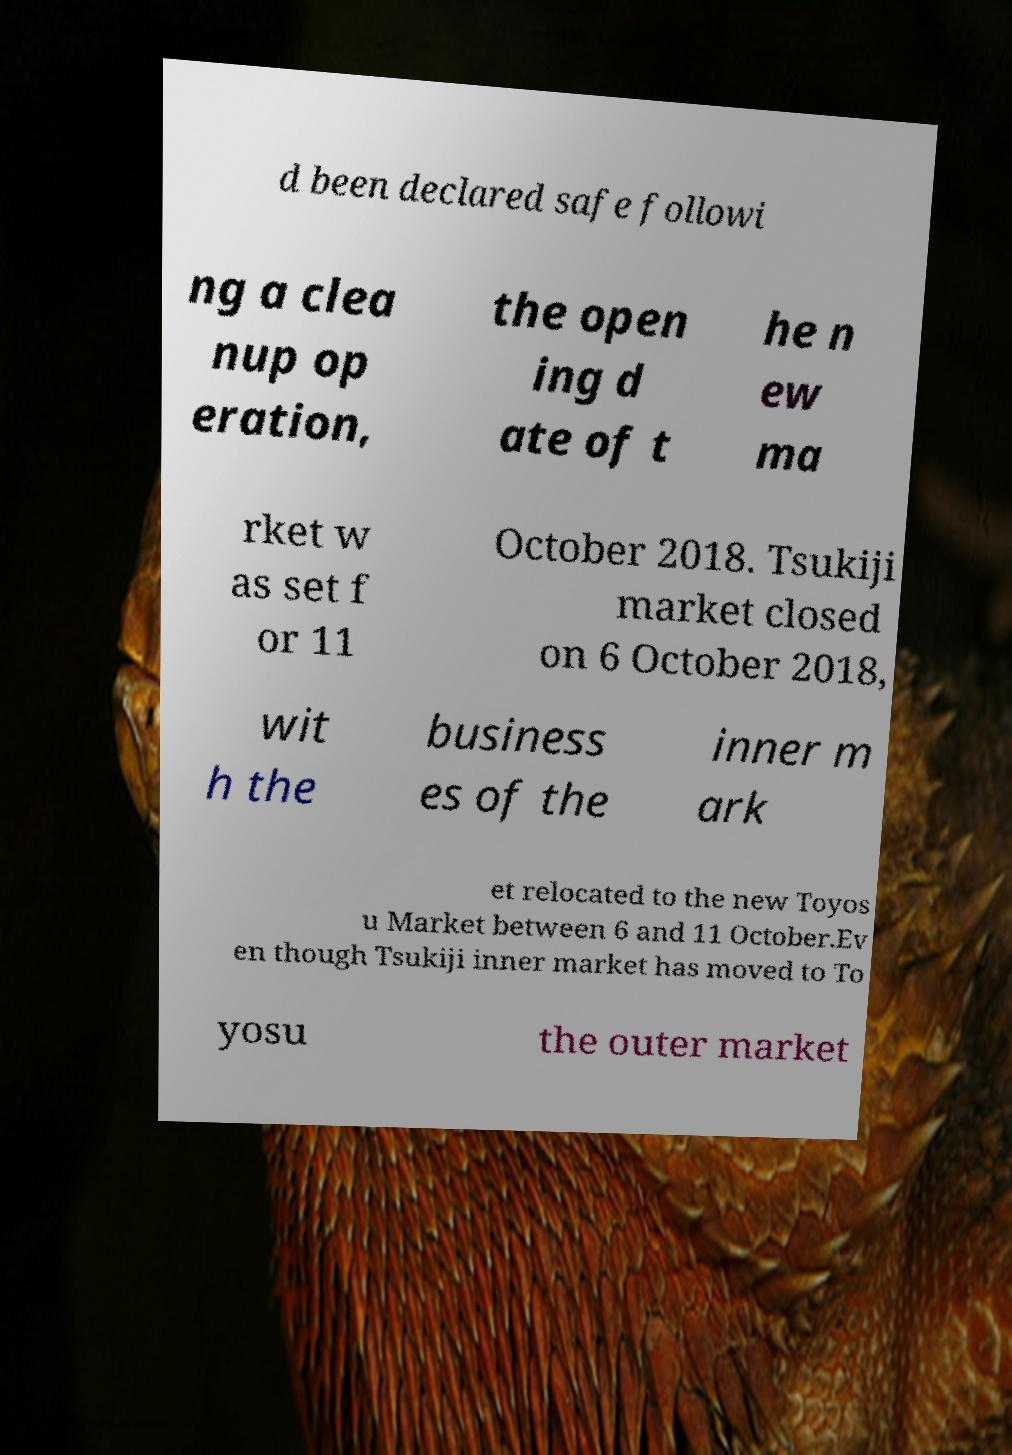What messages or text are displayed in this image? I need them in a readable, typed format. d been declared safe followi ng a clea nup op eration, the open ing d ate of t he n ew ma rket w as set f or 11 October 2018. Tsukiji market closed on 6 October 2018, wit h the business es of the inner m ark et relocated to the new Toyos u Market between 6 and 11 October.Ev en though Tsukiji inner market has moved to To yosu the outer market 